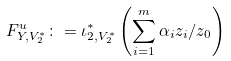Convert formula to latex. <formula><loc_0><loc_0><loc_500><loc_500>F ^ { u } _ { Y , V _ { 2 } ^ { \ast } } \colon = \iota _ { 2 , V _ { 2 } ^ { \ast } } ^ { \ast } \left ( \sum _ { i = 1 } ^ { m } \alpha _ { i } z _ { i } / z _ { 0 } \right )</formula> 